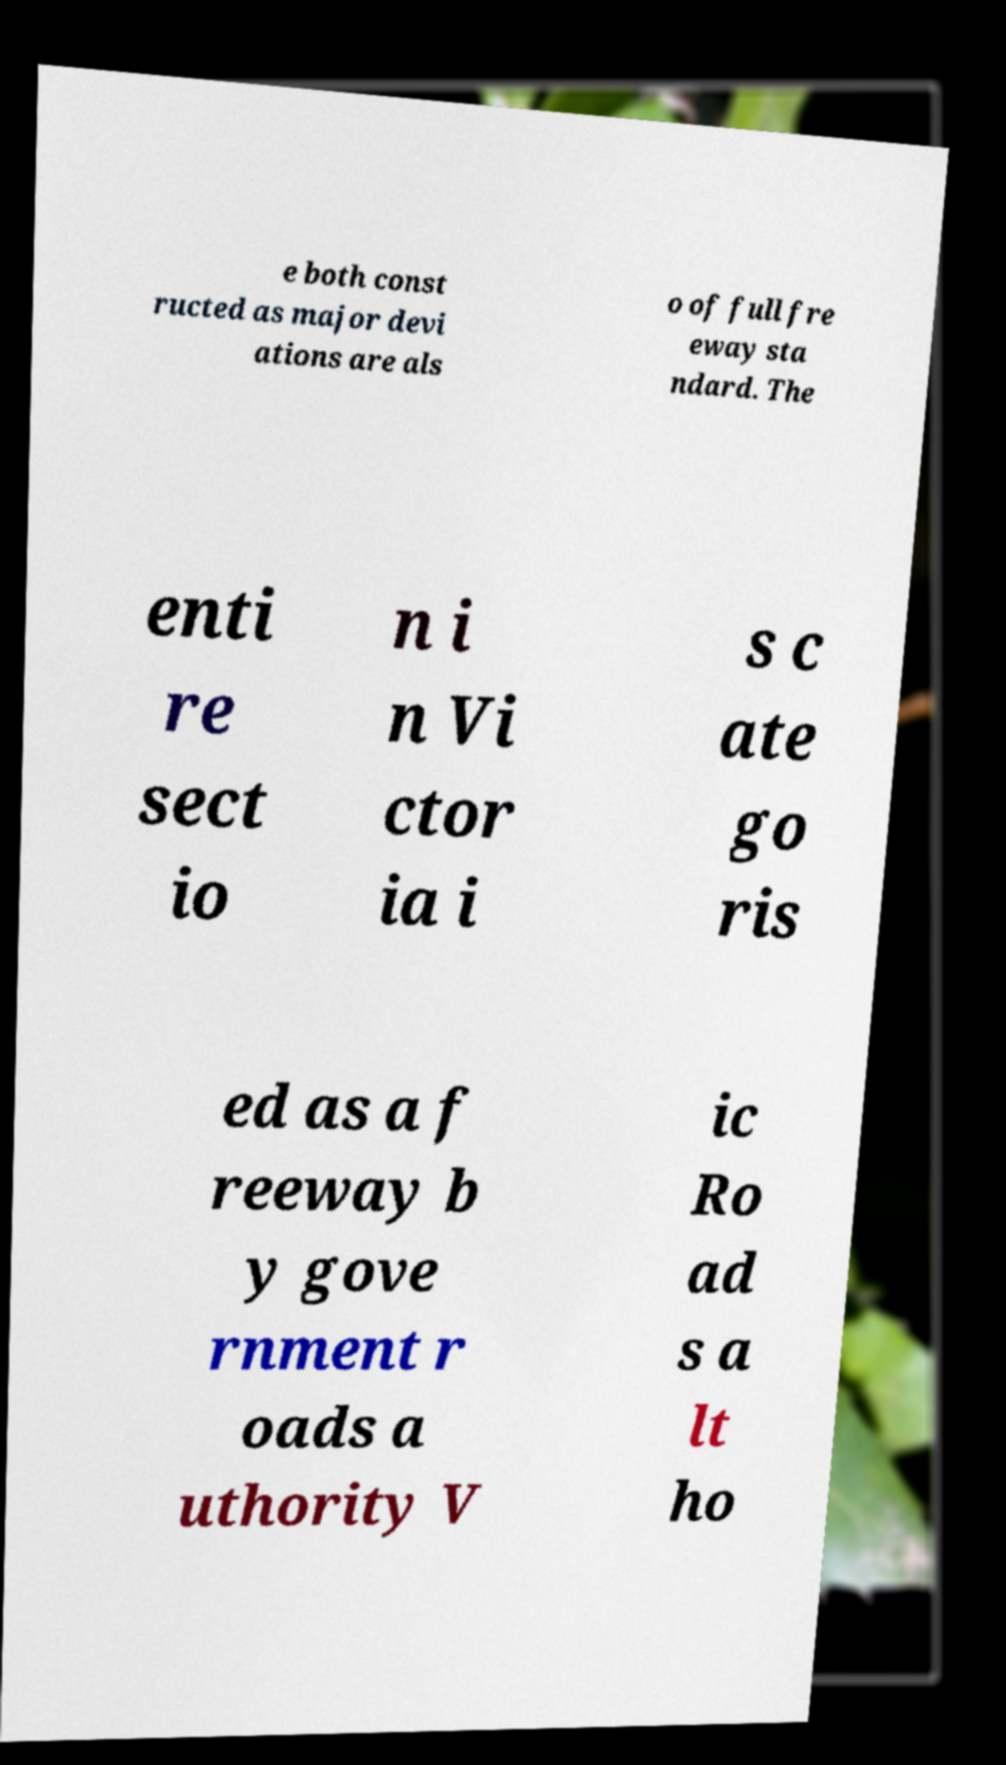There's text embedded in this image that I need extracted. Can you transcribe it verbatim? e both const ructed as major devi ations are als o of full fre eway sta ndard. The enti re sect io n i n Vi ctor ia i s c ate go ris ed as a f reeway b y gove rnment r oads a uthority V ic Ro ad s a lt ho 